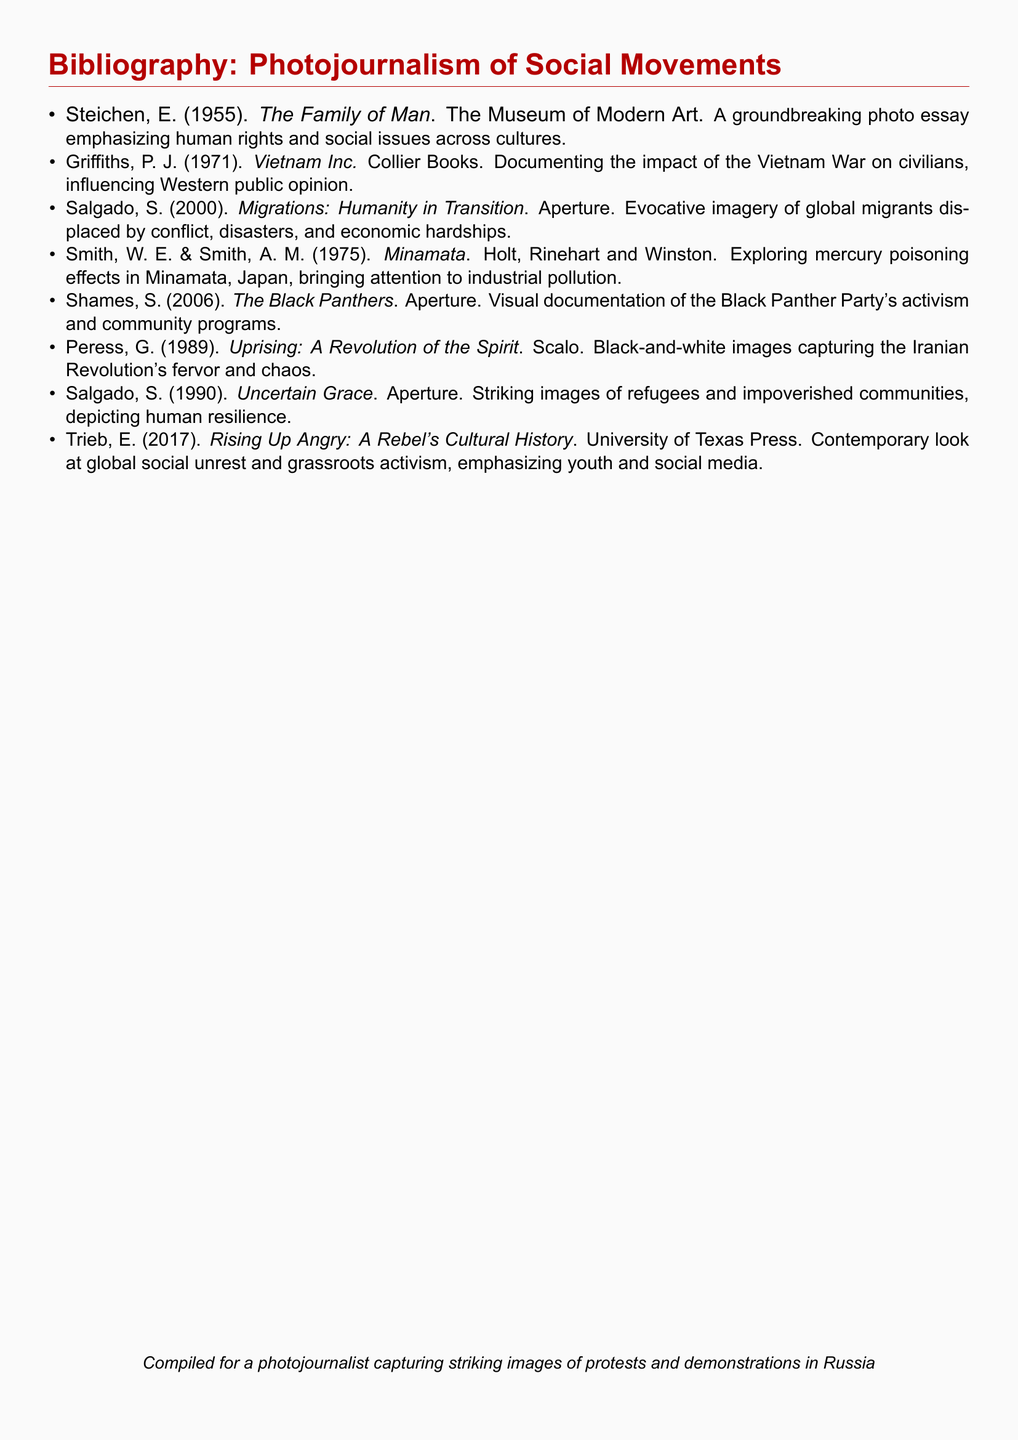What is the title of the first entry? The first entry is titled "The Family of Man."
Answer: The Family of Man Who authored "Vietnam Inc."? "Vietnam Inc." was authored by P. J. Griffiths.
Answer: P. J. Griffiths In what year was "Migrations: Humanity in Transition" published? "Migrations: Humanity in Transition" was published in 2000.
Answer: 2000 How many photo essays in the list were authored by Salgado? There are two photo essays authored by Salgado.
Answer: two What is the common focus of the photo essays listed? The common focus is on social movements and human rights issues.
Answer: social movements Which publication released "The Black Panthers"? "The Black Panthers" was released by Aperture.
Answer: Aperture What type of imagery is prominent in "Uprising: A Revolution of the Spirit"? The imagery in "Uprising" is primarily black-and-white.
Answer: black-and-white Who are the authors of "Minamata"? The authors of "Minamata" are W. E. Smith and A. M. Smith.
Answer: W. E. Smith and A. M. Smith Which year was "Rising Up Angry: A Rebel's Cultural History" published? "Rising Up Angry" was published in 2017.
Answer: 2017 